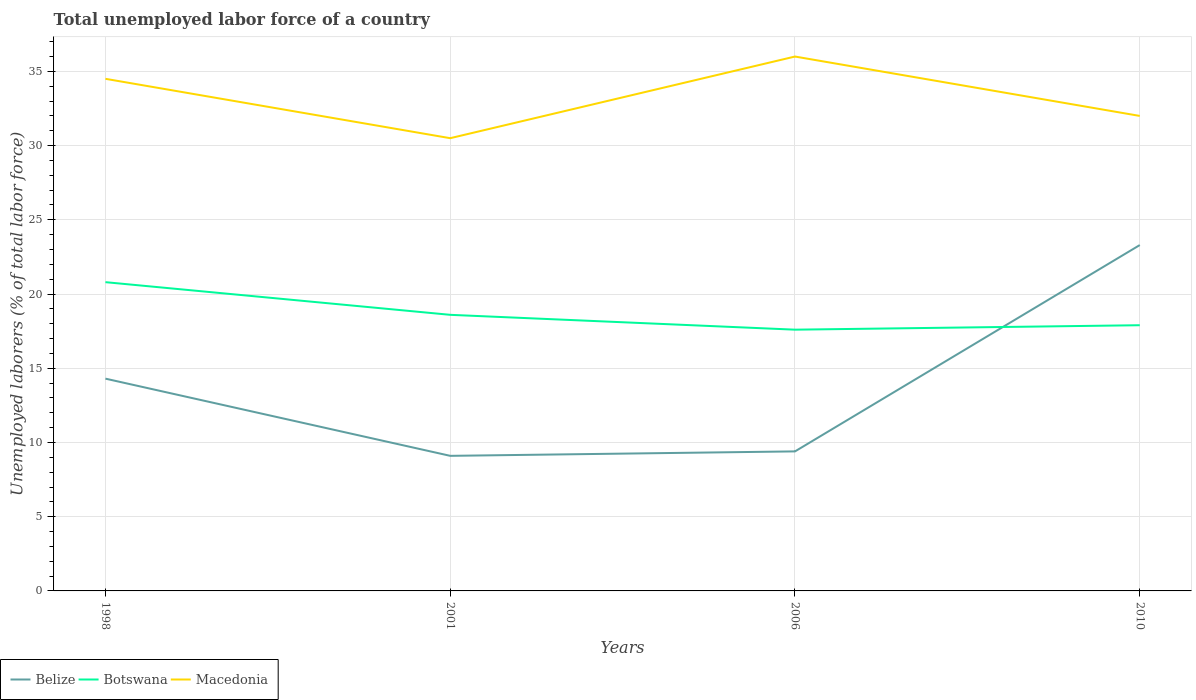How many different coloured lines are there?
Your response must be concise. 3. Does the line corresponding to Belize intersect with the line corresponding to Macedonia?
Give a very brief answer. No. Is the number of lines equal to the number of legend labels?
Your response must be concise. Yes. Across all years, what is the maximum total unemployed labor force in Belize?
Make the answer very short. 9.1. What is the total total unemployed labor force in Botswana in the graph?
Your response must be concise. -0.3. What is the difference between the highest and the second highest total unemployed labor force in Belize?
Provide a succinct answer. 14.2. Is the total unemployed labor force in Botswana strictly greater than the total unemployed labor force in Macedonia over the years?
Keep it short and to the point. Yes. How many lines are there?
Offer a terse response. 3. How many years are there in the graph?
Provide a succinct answer. 4. What is the difference between two consecutive major ticks on the Y-axis?
Provide a succinct answer. 5. Are the values on the major ticks of Y-axis written in scientific E-notation?
Give a very brief answer. No. How many legend labels are there?
Provide a succinct answer. 3. How are the legend labels stacked?
Your answer should be compact. Horizontal. What is the title of the graph?
Provide a succinct answer. Total unemployed labor force of a country. What is the label or title of the Y-axis?
Give a very brief answer. Unemployed laborers (% of total labor force). What is the Unemployed laborers (% of total labor force) in Belize in 1998?
Your answer should be compact. 14.3. What is the Unemployed laborers (% of total labor force) of Botswana in 1998?
Provide a short and direct response. 20.8. What is the Unemployed laborers (% of total labor force) of Macedonia in 1998?
Your answer should be very brief. 34.5. What is the Unemployed laborers (% of total labor force) of Belize in 2001?
Keep it short and to the point. 9.1. What is the Unemployed laborers (% of total labor force) in Botswana in 2001?
Provide a short and direct response. 18.6. What is the Unemployed laborers (% of total labor force) of Macedonia in 2001?
Offer a very short reply. 30.5. What is the Unemployed laborers (% of total labor force) of Belize in 2006?
Keep it short and to the point. 9.4. What is the Unemployed laborers (% of total labor force) in Botswana in 2006?
Your answer should be compact. 17.6. What is the Unemployed laborers (% of total labor force) in Belize in 2010?
Ensure brevity in your answer.  23.3. What is the Unemployed laborers (% of total labor force) of Botswana in 2010?
Offer a very short reply. 17.9. What is the Unemployed laborers (% of total labor force) of Macedonia in 2010?
Your answer should be very brief. 32. Across all years, what is the maximum Unemployed laborers (% of total labor force) of Belize?
Provide a short and direct response. 23.3. Across all years, what is the maximum Unemployed laborers (% of total labor force) in Botswana?
Make the answer very short. 20.8. Across all years, what is the minimum Unemployed laborers (% of total labor force) in Belize?
Provide a short and direct response. 9.1. Across all years, what is the minimum Unemployed laborers (% of total labor force) in Botswana?
Your response must be concise. 17.6. Across all years, what is the minimum Unemployed laborers (% of total labor force) in Macedonia?
Your response must be concise. 30.5. What is the total Unemployed laborers (% of total labor force) of Belize in the graph?
Provide a short and direct response. 56.1. What is the total Unemployed laborers (% of total labor force) of Botswana in the graph?
Your answer should be very brief. 74.9. What is the total Unemployed laborers (% of total labor force) in Macedonia in the graph?
Offer a terse response. 133. What is the difference between the Unemployed laborers (% of total labor force) of Belize in 1998 and that in 2006?
Ensure brevity in your answer.  4.9. What is the difference between the Unemployed laborers (% of total labor force) in Botswana in 1998 and that in 2006?
Offer a very short reply. 3.2. What is the difference between the Unemployed laborers (% of total labor force) of Macedonia in 1998 and that in 2006?
Provide a short and direct response. -1.5. What is the difference between the Unemployed laborers (% of total labor force) in Botswana in 1998 and that in 2010?
Give a very brief answer. 2.9. What is the difference between the Unemployed laborers (% of total labor force) in Macedonia in 1998 and that in 2010?
Your answer should be very brief. 2.5. What is the difference between the Unemployed laborers (% of total labor force) in Belize in 2001 and that in 2006?
Your answer should be compact. -0.3. What is the difference between the Unemployed laborers (% of total labor force) in Macedonia in 2001 and that in 2006?
Your answer should be compact. -5.5. What is the difference between the Unemployed laborers (% of total labor force) of Belize in 2001 and that in 2010?
Offer a very short reply. -14.2. What is the difference between the Unemployed laborers (% of total labor force) of Botswana in 2001 and that in 2010?
Offer a very short reply. 0.7. What is the difference between the Unemployed laborers (% of total labor force) in Macedonia in 2001 and that in 2010?
Provide a short and direct response. -1.5. What is the difference between the Unemployed laborers (% of total labor force) of Belize in 2006 and that in 2010?
Provide a short and direct response. -13.9. What is the difference between the Unemployed laborers (% of total labor force) of Botswana in 2006 and that in 2010?
Your answer should be very brief. -0.3. What is the difference between the Unemployed laborers (% of total labor force) of Macedonia in 2006 and that in 2010?
Offer a terse response. 4. What is the difference between the Unemployed laborers (% of total labor force) in Belize in 1998 and the Unemployed laborers (% of total labor force) in Macedonia in 2001?
Your answer should be very brief. -16.2. What is the difference between the Unemployed laborers (% of total labor force) in Botswana in 1998 and the Unemployed laborers (% of total labor force) in Macedonia in 2001?
Offer a very short reply. -9.7. What is the difference between the Unemployed laborers (% of total labor force) of Belize in 1998 and the Unemployed laborers (% of total labor force) of Macedonia in 2006?
Give a very brief answer. -21.7. What is the difference between the Unemployed laborers (% of total labor force) in Botswana in 1998 and the Unemployed laborers (% of total labor force) in Macedonia in 2006?
Make the answer very short. -15.2. What is the difference between the Unemployed laborers (% of total labor force) of Belize in 1998 and the Unemployed laborers (% of total labor force) of Macedonia in 2010?
Your response must be concise. -17.7. What is the difference between the Unemployed laborers (% of total labor force) in Belize in 2001 and the Unemployed laborers (% of total labor force) in Macedonia in 2006?
Offer a terse response. -26.9. What is the difference between the Unemployed laborers (% of total labor force) of Botswana in 2001 and the Unemployed laborers (% of total labor force) of Macedonia in 2006?
Your answer should be compact. -17.4. What is the difference between the Unemployed laborers (% of total labor force) of Belize in 2001 and the Unemployed laborers (% of total labor force) of Botswana in 2010?
Your answer should be very brief. -8.8. What is the difference between the Unemployed laborers (% of total labor force) in Belize in 2001 and the Unemployed laborers (% of total labor force) in Macedonia in 2010?
Give a very brief answer. -22.9. What is the difference between the Unemployed laborers (% of total labor force) in Belize in 2006 and the Unemployed laborers (% of total labor force) in Macedonia in 2010?
Give a very brief answer. -22.6. What is the difference between the Unemployed laborers (% of total labor force) in Botswana in 2006 and the Unemployed laborers (% of total labor force) in Macedonia in 2010?
Give a very brief answer. -14.4. What is the average Unemployed laborers (% of total labor force) of Belize per year?
Offer a very short reply. 14.03. What is the average Unemployed laborers (% of total labor force) of Botswana per year?
Keep it short and to the point. 18.73. What is the average Unemployed laborers (% of total labor force) in Macedonia per year?
Ensure brevity in your answer.  33.25. In the year 1998, what is the difference between the Unemployed laborers (% of total labor force) of Belize and Unemployed laborers (% of total labor force) of Botswana?
Offer a terse response. -6.5. In the year 1998, what is the difference between the Unemployed laborers (% of total labor force) in Belize and Unemployed laborers (% of total labor force) in Macedonia?
Provide a succinct answer. -20.2. In the year 1998, what is the difference between the Unemployed laborers (% of total labor force) of Botswana and Unemployed laborers (% of total labor force) of Macedonia?
Keep it short and to the point. -13.7. In the year 2001, what is the difference between the Unemployed laborers (% of total labor force) of Belize and Unemployed laborers (% of total labor force) of Macedonia?
Your answer should be compact. -21.4. In the year 2001, what is the difference between the Unemployed laborers (% of total labor force) in Botswana and Unemployed laborers (% of total labor force) in Macedonia?
Your answer should be compact. -11.9. In the year 2006, what is the difference between the Unemployed laborers (% of total labor force) in Belize and Unemployed laborers (% of total labor force) in Macedonia?
Provide a short and direct response. -26.6. In the year 2006, what is the difference between the Unemployed laborers (% of total labor force) of Botswana and Unemployed laborers (% of total labor force) of Macedonia?
Provide a succinct answer. -18.4. In the year 2010, what is the difference between the Unemployed laborers (% of total labor force) of Belize and Unemployed laborers (% of total labor force) of Botswana?
Provide a succinct answer. 5.4. In the year 2010, what is the difference between the Unemployed laborers (% of total labor force) in Botswana and Unemployed laborers (% of total labor force) in Macedonia?
Provide a short and direct response. -14.1. What is the ratio of the Unemployed laborers (% of total labor force) of Belize in 1998 to that in 2001?
Your answer should be compact. 1.57. What is the ratio of the Unemployed laborers (% of total labor force) of Botswana in 1998 to that in 2001?
Ensure brevity in your answer.  1.12. What is the ratio of the Unemployed laborers (% of total labor force) in Macedonia in 1998 to that in 2001?
Provide a short and direct response. 1.13. What is the ratio of the Unemployed laborers (% of total labor force) of Belize in 1998 to that in 2006?
Ensure brevity in your answer.  1.52. What is the ratio of the Unemployed laborers (% of total labor force) in Botswana in 1998 to that in 2006?
Your response must be concise. 1.18. What is the ratio of the Unemployed laborers (% of total labor force) of Belize in 1998 to that in 2010?
Ensure brevity in your answer.  0.61. What is the ratio of the Unemployed laborers (% of total labor force) in Botswana in 1998 to that in 2010?
Your answer should be compact. 1.16. What is the ratio of the Unemployed laborers (% of total labor force) of Macedonia in 1998 to that in 2010?
Your answer should be compact. 1.08. What is the ratio of the Unemployed laborers (% of total labor force) of Belize in 2001 to that in 2006?
Your answer should be very brief. 0.97. What is the ratio of the Unemployed laborers (% of total labor force) in Botswana in 2001 to that in 2006?
Give a very brief answer. 1.06. What is the ratio of the Unemployed laborers (% of total labor force) of Macedonia in 2001 to that in 2006?
Provide a succinct answer. 0.85. What is the ratio of the Unemployed laborers (% of total labor force) of Belize in 2001 to that in 2010?
Provide a short and direct response. 0.39. What is the ratio of the Unemployed laborers (% of total labor force) in Botswana in 2001 to that in 2010?
Provide a short and direct response. 1.04. What is the ratio of the Unemployed laborers (% of total labor force) in Macedonia in 2001 to that in 2010?
Your response must be concise. 0.95. What is the ratio of the Unemployed laborers (% of total labor force) of Belize in 2006 to that in 2010?
Keep it short and to the point. 0.4. What is the ratio of the Unemployed laborers (% of total labor force) of Botswana in 2006 to that in 2010?
Your answer should be compact. 0.98. What is the ratio of the Unemployed laborers (% of total labor force) of Macedonia in 2006 to that in 2010?
Your answer should be compact. 1.12. What is the difference between the highest and the second highest Unemployed laborers (% of total labor force) in Belize?
Make the answer very short. 9. What is the difference between the highest and the second highest Unemployed laborers (% of total labor force) in Macedonia?
Your response must be concise. 1.5. What is the difference between the highest and the lowest Unemployed laborers (% of total labor force) of Botswana?
Keep it short and to the point. 3.2. What is the difference between the highest and the lowest Unemployed laborers (% of total labor force) of Macedonia?
Keep it short and to the point. 5.5. 